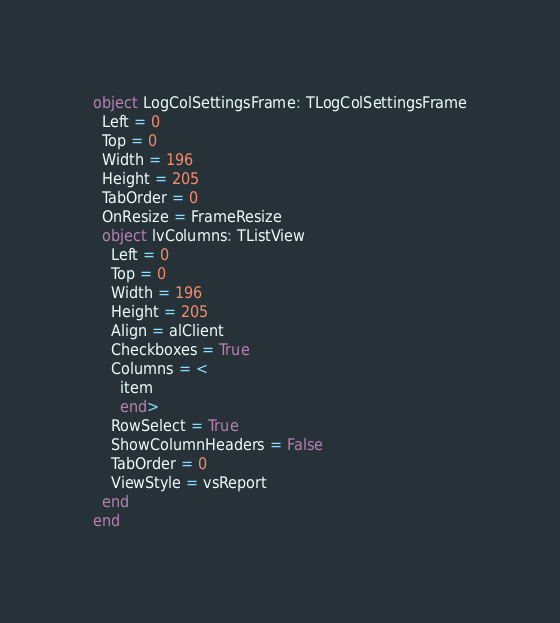<code> <loc_0><loc_0><loc_500><loc_500><_Pascal_>object LogColSettingsFrame: TLogColSettingsFrame
  Left = 0
  Top = 0
  Width = 196
  Height = 205
  TabOrder = 0
  OnResize = FrameResize
  object lvColumns: TListView
    Left = 0
    Top = 0
    Width = 196
    Height = 205
    Align = alClient
    Checkboxes = True
    Columns = <
      item
      end>
    RowSelect = True
    ShowColumnHeaders = False
    TabOrder = 0
    ViewStyle = vsReport
  end
end
</code> 